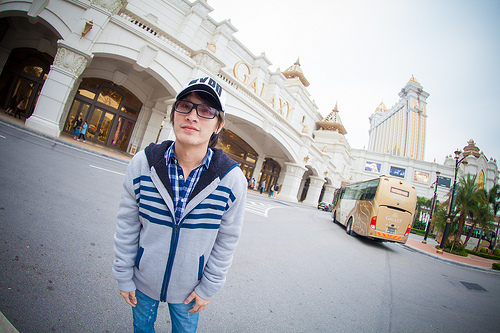<image>
Is there a man in the building? No. The man is not contained within the building. These objects have a different spatial relationship. 